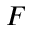Convert formula to latex. <formula><loc_0><loc_0><loc_500><loc_500>F</formula> 